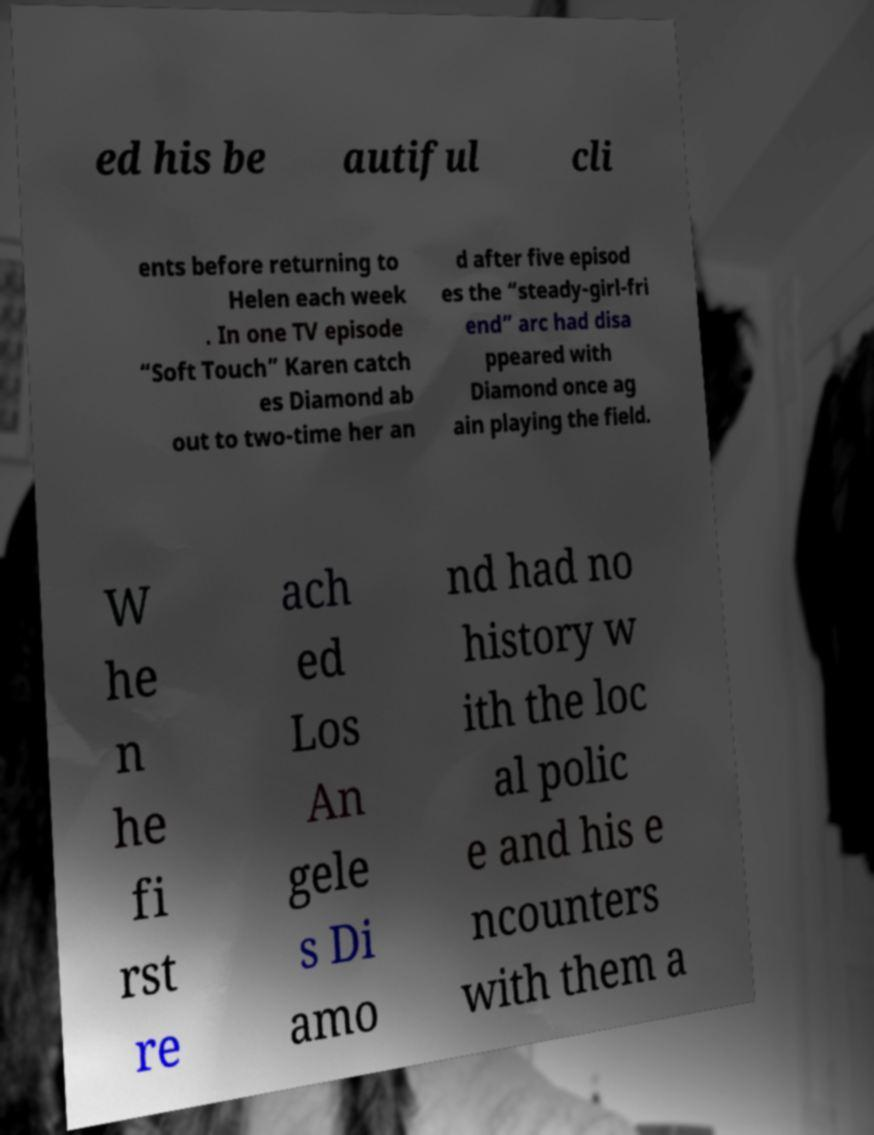Can you accurately transcribe the text from the provided image for me? ed his be autiful cli ents before returning to Helen each week . In one TV episode “Soft Touch” Karen catch es Diamond ab out to two-time her an d after five episod es the “steady-girl-fri end” arc had disa ppeared with Diamond once ag ain playing the field. W he n he fi rst re ach ed Los An gele s Di amo nd had no history w ith the loc al polic e and his e ncounters with them a 